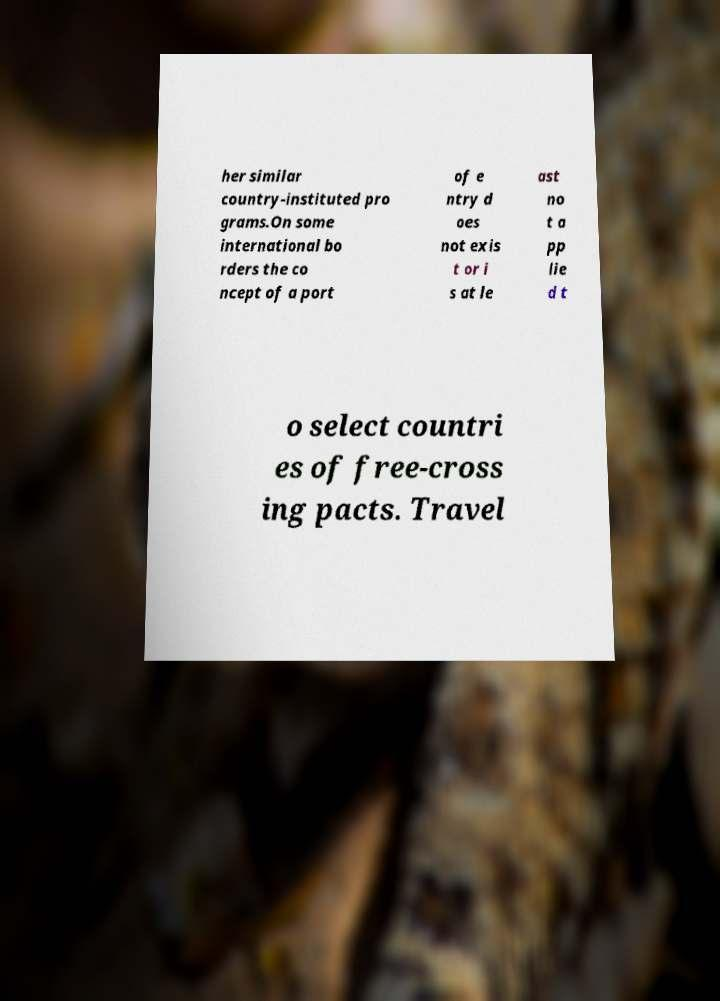Could you assist in decoding the text presented in this image and type it out clearly? her similar country-instituted pro grams.On some international bo rders the co ncept of a port of e ntry d oes not exis t or i s at le ast no t a pp lie d t o select countri es of free-cross ing pacts. Travel 